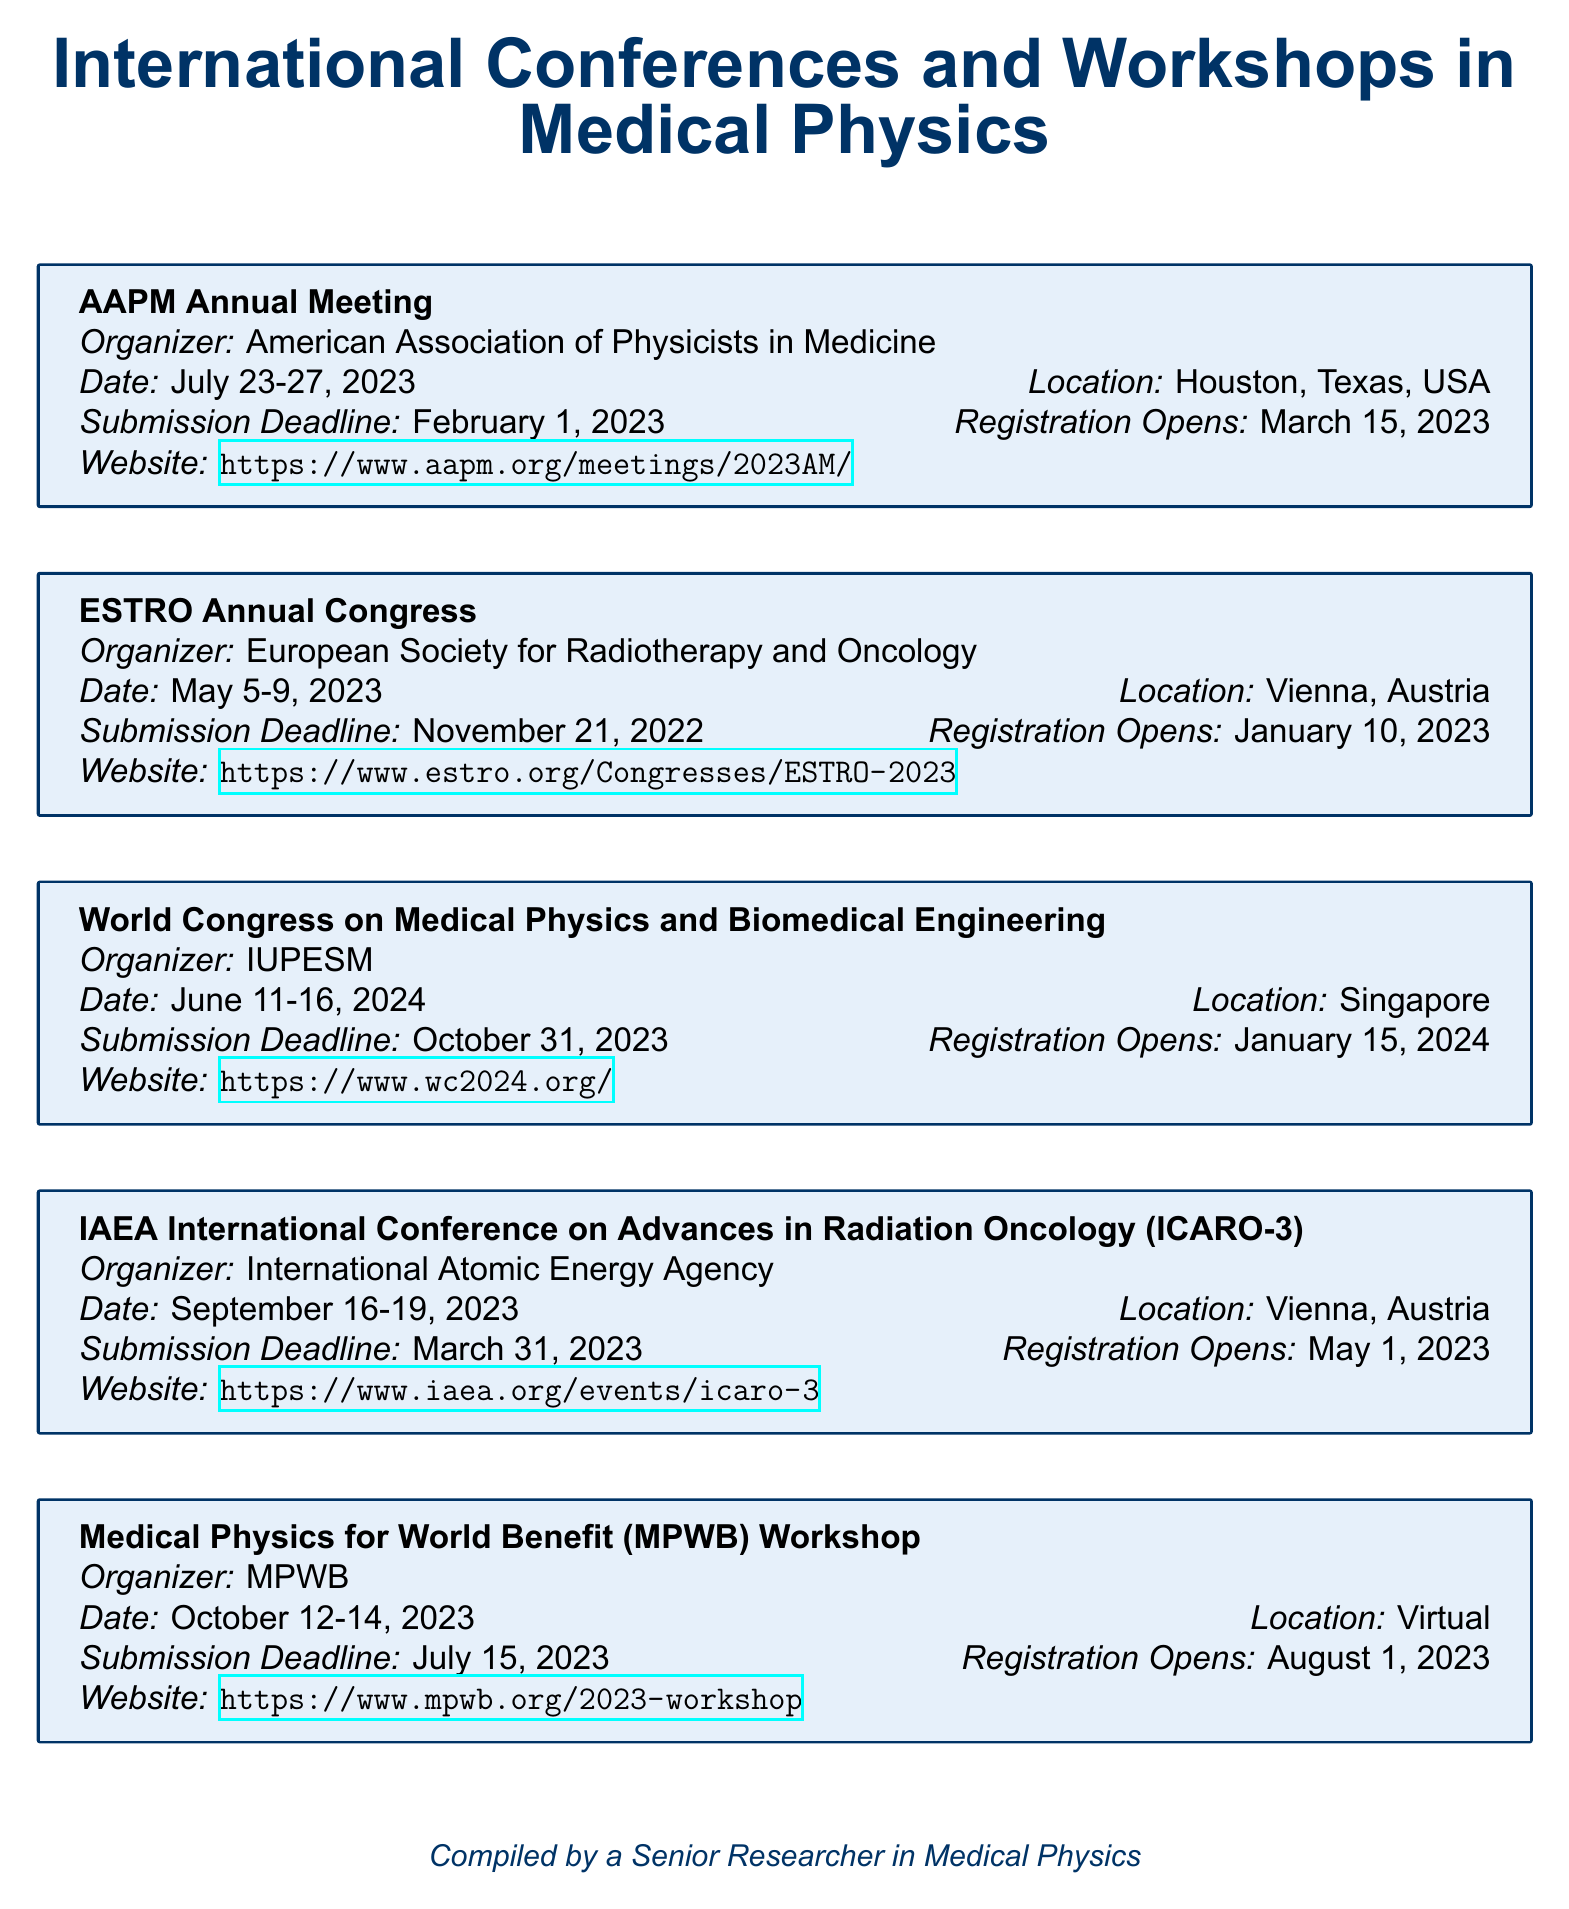What is the date of the AAPM Annual Meeting? The date of the AAPM Annual Meeting is specified in the document as July 23-27, 2023.
Answer: July 23-27, 2023 Where is the ESTRO Annual Congress located? The location of the ESTRO Annual Congress is provided in the document as Vienna, Austria.
Answer: Vienna, Austria What is the submission deadline for the World Congress on Medical Physics and Biomedical Engineering? The submission deadline for the World Congress on Medical Physics and Biomedical Engineering is noted as October 31, 2023.
Answer: October 31, 2023 How many days will the Medical Physics for World Benefit Workshop take place? The duration of the Medical Physics for World Benefit Workshop can be inferred from the date range of October 12-14, 2023, indicating it spans three days.
Answer: Three days What organization is responsible for the IAEA International Conference on Advances in Radiation Oncology? The organizing body for the IAEA International Conference is mentioned as the International Atomic Energy Agency.
Answer: International Atomic Energy Agency Which conference has the earliest registration opening date? By comparing the registration opening dates in the document, the ESTRO Annual Congress has the earliest opening date of January 10, 2023.
Answer: January 10, 2023 What type of event is the Medical Physics for World Benefit Workshop? The document specifies that the Medical Physics for World Benefit Workshop is a virtual event, indicating its format.
Answer: Virtual How many total events are listed in the document? By counting the separate entries in the document, there are five conferences and workshops listed.
Answer: Five events 